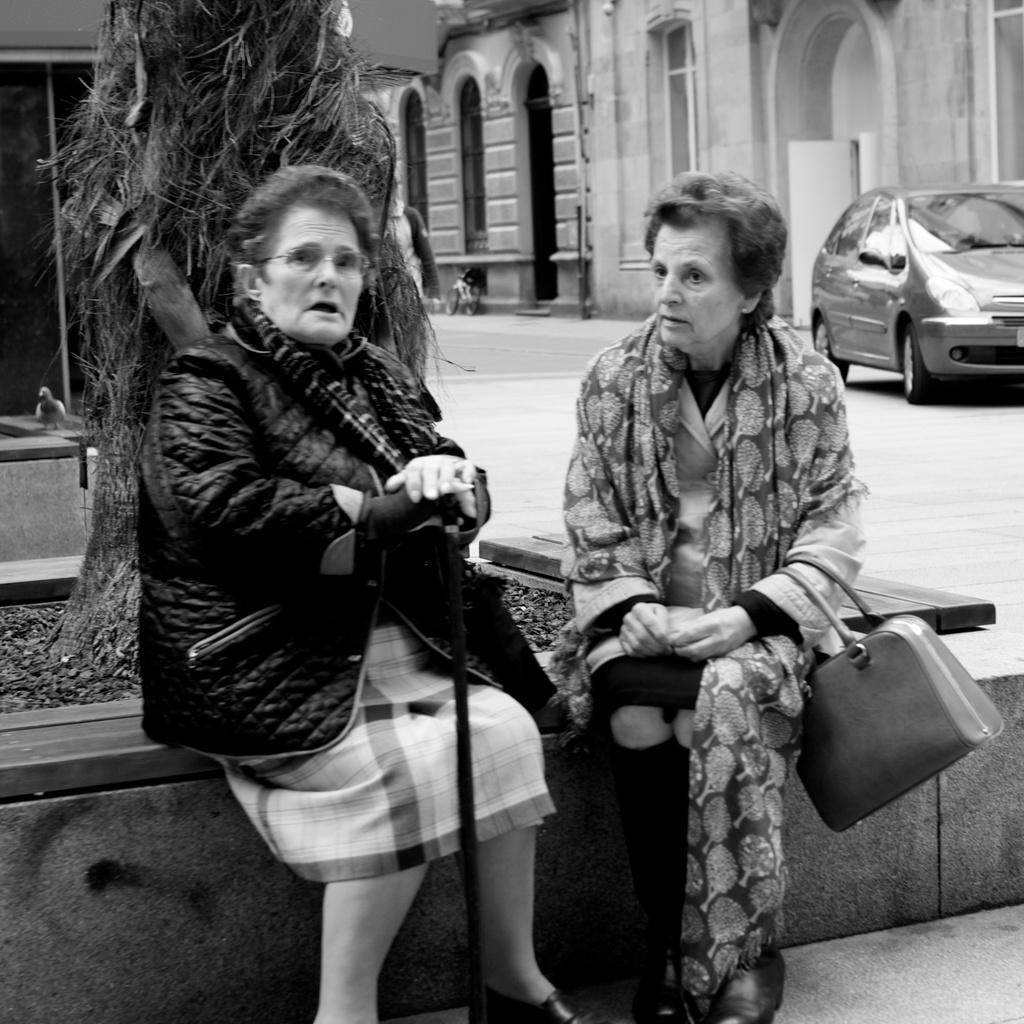Could you give a brief overview of what you see in this image? As we can see in the image in the front there are two people sitting. There is a tree stem, buildings and car. 